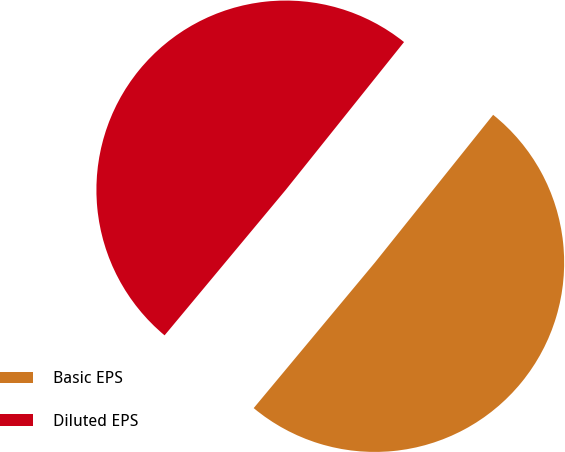Convert chart to OTSL. <chart><loc_0><loc_0><loc_500><loc_500><pie_chart><fcel>Basic EPS<fcel>Diluted EPS<nl><fcel>50.31%<fcel>49.69%<nl></chart> 